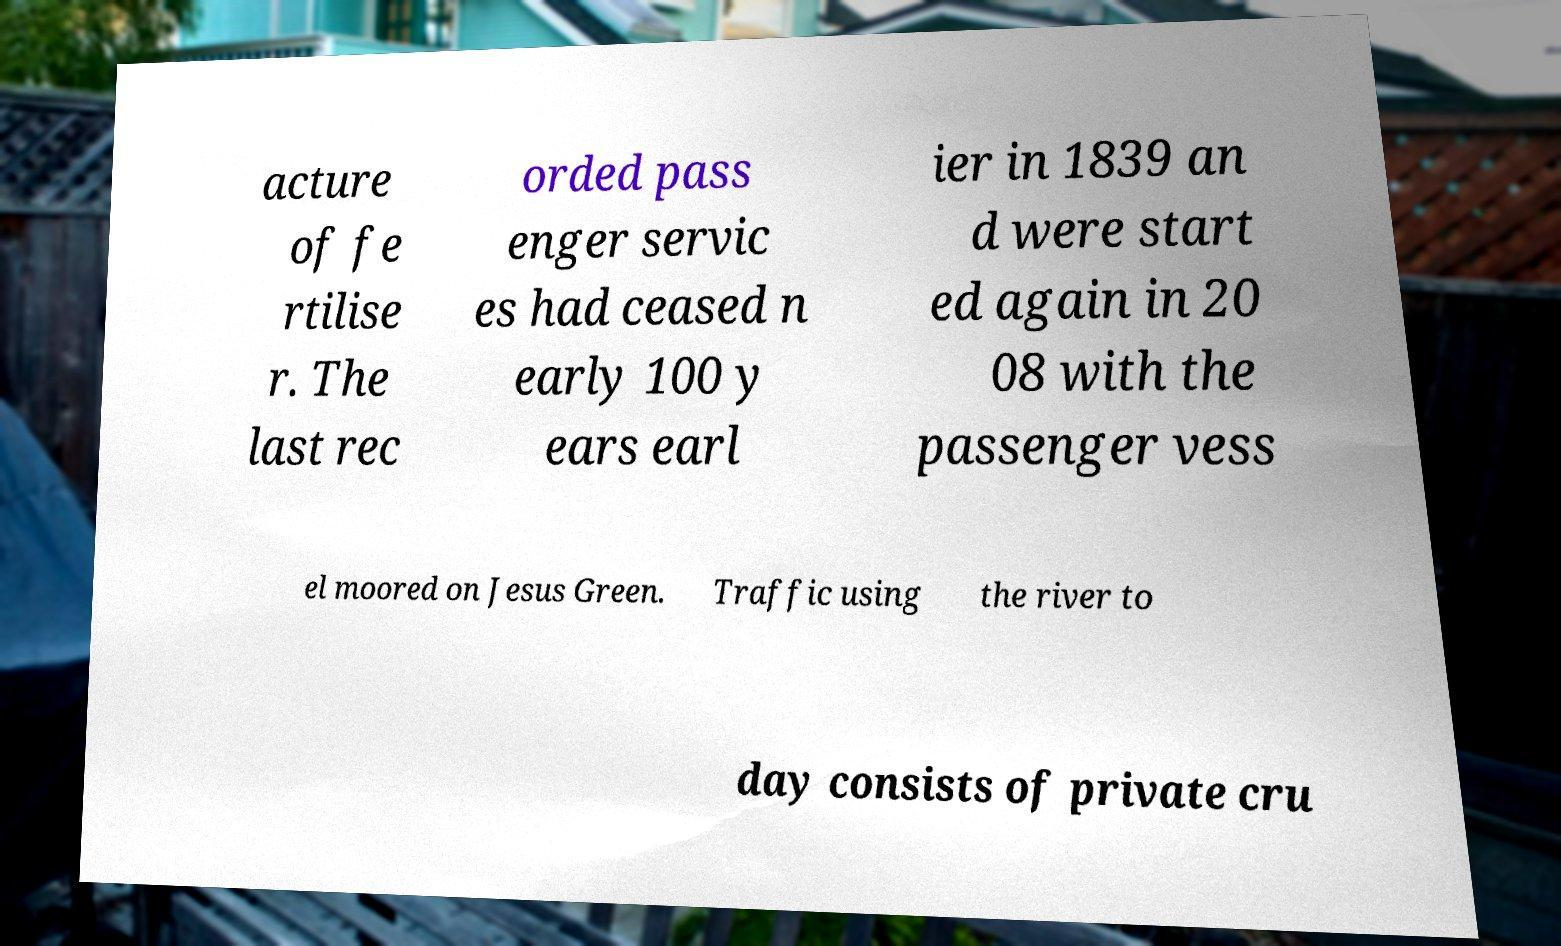Please identify and transcribe the text found in this image. acture of fe rtilise r. The last rec orded pass enger servic es had ceased n early 100 y ears earl ier in 1839 an d were start ed again in 20 08 with the passenger vess el moored on Jesus Green. Traffic using the river to day consists of private cru 